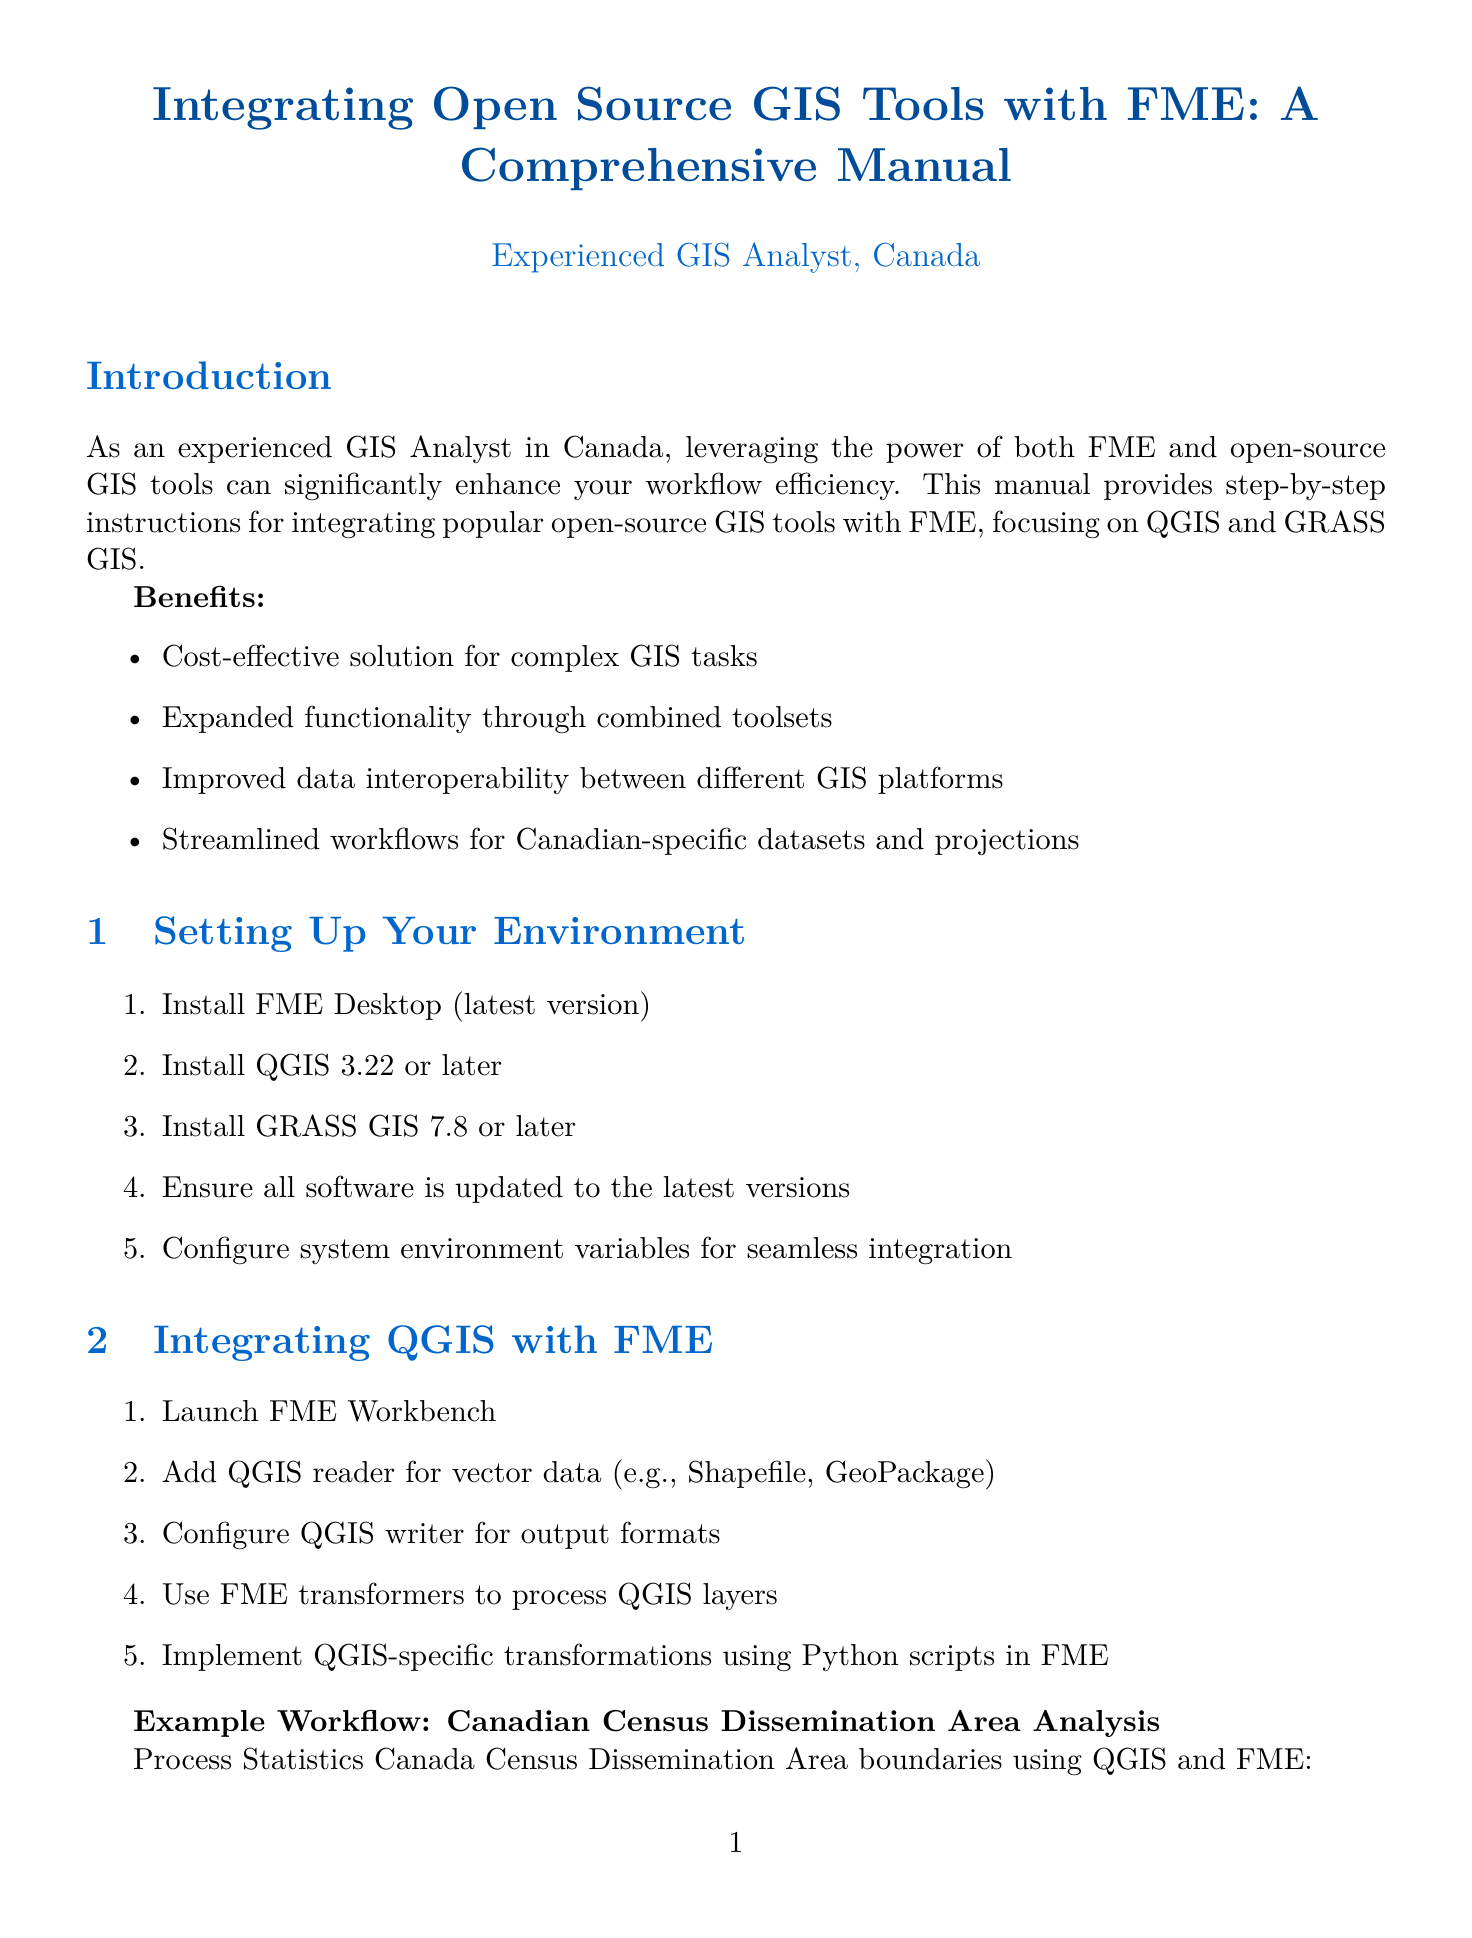What is the title of the manual? The title of the manual is presented at the start of the document, highlighting its focus on the integration of GIS tools with FME.
Answer: Integrating Open Source GIS Tools with FME: A Comprehensive Manual What version of QGIS is required? The requirements for QGIS are listed in the "Setting Up Your Environment" section, specifying the minimum version needed for integration.
Answer: 3.22 or later What example workflow is used for QGIS integration? An example workflow that showcases QGIS integration with FME is mentioned in the section on integrating QGIS.
Answer: Canadian Census Dissemination Area Analysis Which GRASS GIS module is utilized in the LiDAR DEM processing example? The example workflow for GRASS GIS integration specifies the command/module used for the analysis of flood risk.
Answer: r.watershed What is one benefit of integrating open-source GIS tools with FME? The benefits of integration are mentioned in the introduction, summarizing the advantages for GIS analysts.
Answer: Cost-effective solution for complex GIS tasks What common issue is related to GRASS GIS commands in FME? The troubleshooting section outlines common problems encountered during the integration process, including issues specifically tied to GRASS GIS commands.
Answer: GRASS GIS command fails in FME SystemCaller What is recommended for large datasets to improve performance? Best practices for optimizing workflows are listed, including specific techniques for handling large datasets effectively.
Answer: Use FME cached readers What is the next step suggested for users after completing the manual? The "Next Steps" section in the conclusion provides actionable suggestions for further exploration and community involvement post-manual usage.
Answer: Explore additional open-source GIS tools for integration 